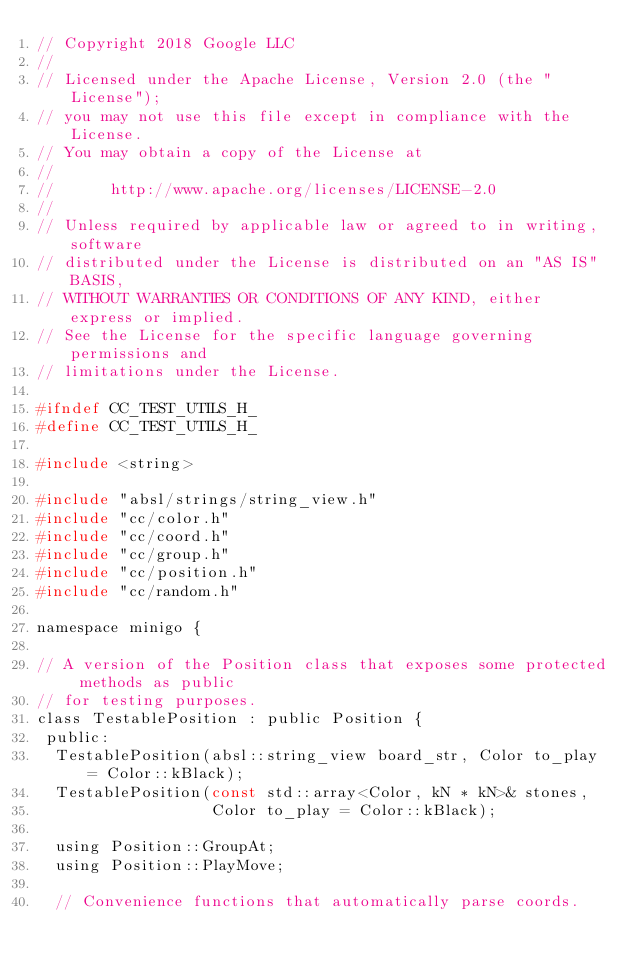Convert code to text. <code><loc_0><loc_0><loc_500><loc_500><_C_>// Copyright 2018 Google LLC
//
// Licensed under the Apache License, Version 2.0 (the "License");
// you may not use this file except in compliance with the License.
// You may obtain a copy of the License at
//
//      http://www.apache.org/licenses/LICENSE-2.0
//
// Unless required by applicable law or agreed to in writing, software
// distributed under the License is distributed on an "AS IS" BASIS,
// WITHOUT WARRANTIES OR CONDITIONS OF ANY KIND, either express or implied.
// See the License for the specific language governing permissions and
// limitations under the License.

#ifndef CC_TEST_UTILS_H_
#define CC_TEST_UTILS_H_

#include <string>

#include "absl/strings/string_view.h"
#include "cc/color.h"
#include "cc/coord.h"
#include "cc/group.h"
#include "cc/position.h"
#include "cc/random.h"

namespace minigo {

// A version of the Position class that exposes some protected methods as public
// for testing purposes.
class TestablePosition : public Position {
 public:
  TestablePosition(absl::string_view board_str, Color to_play = Color::kBlack);
  TestablePosition(const std::array<Color, kN * kN>& stones,
                   Color to_play = Color::kBlack);

  using Position::GroupAt;
  using Position::PlayMove;

  // Convenience functions that automatically parse coords.</code> 